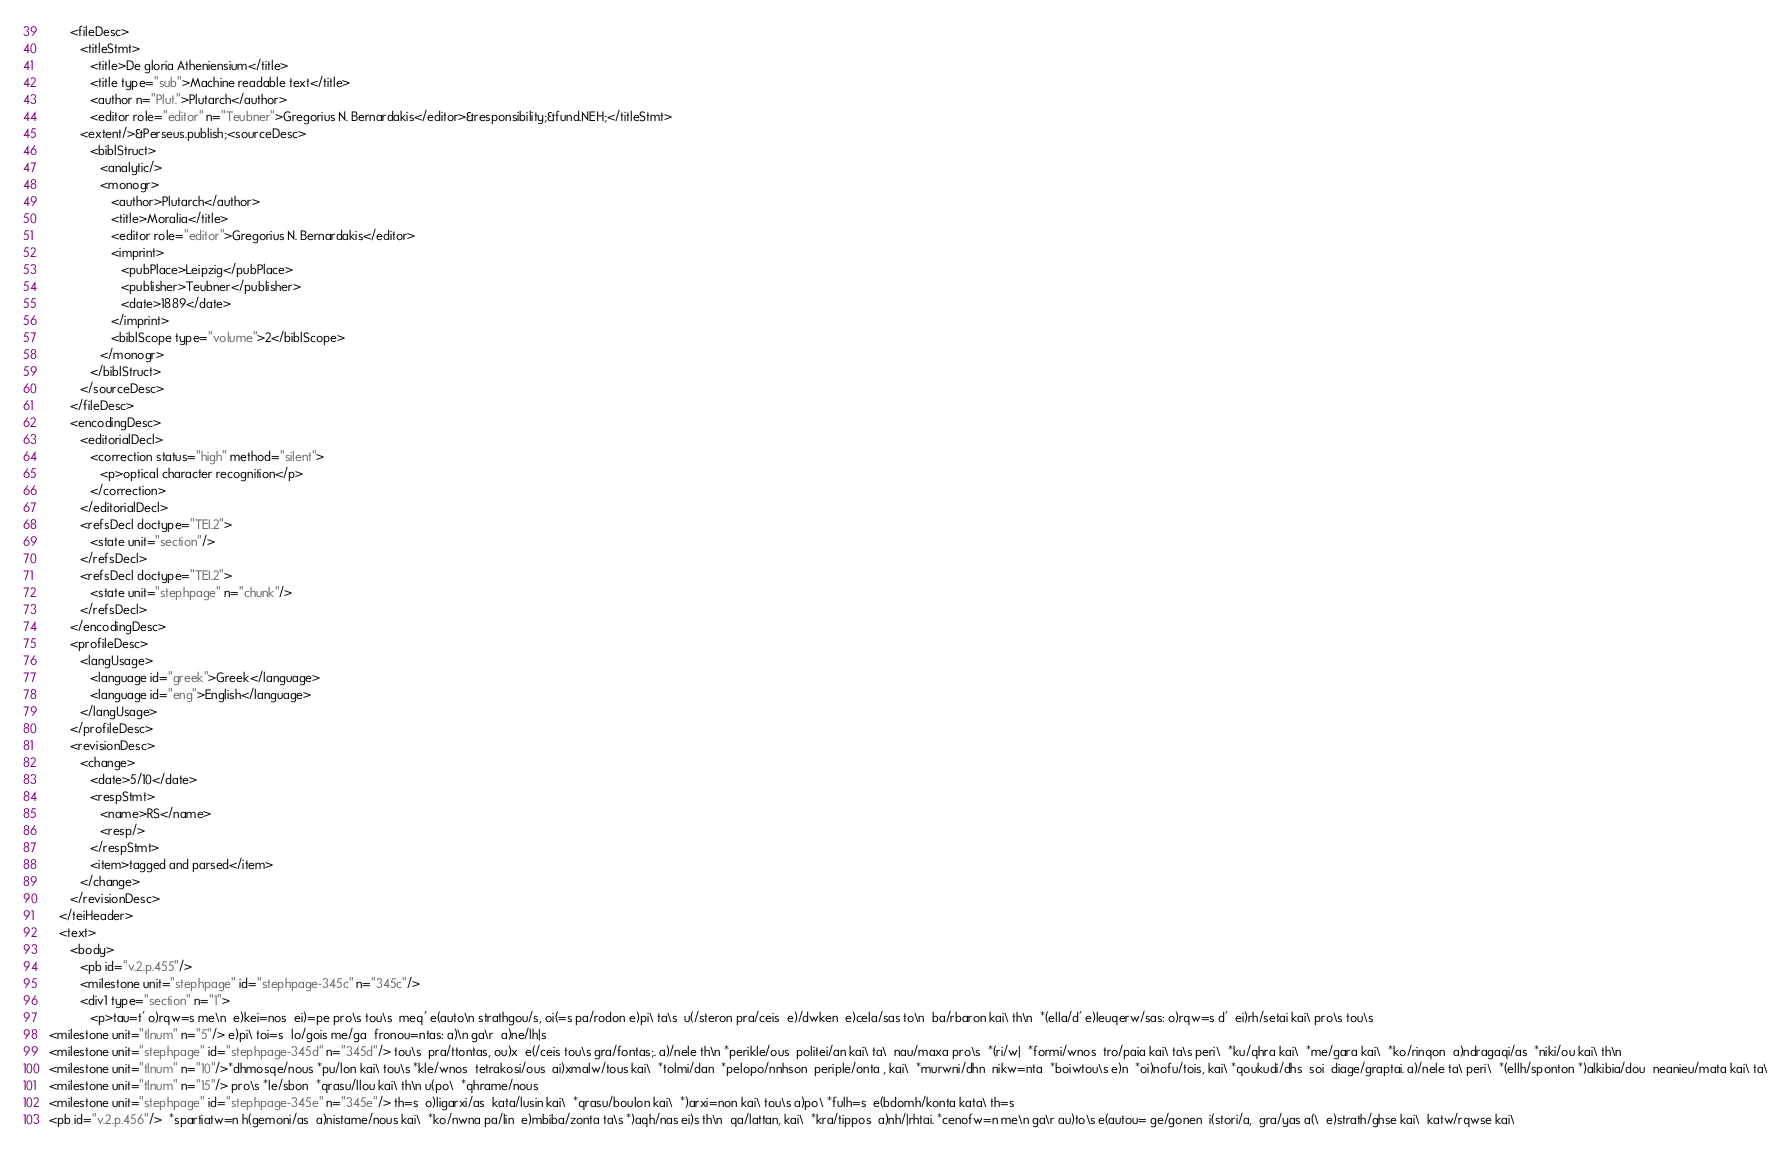Convert code to text. <code><loc_0><loc_0><loc_500><loc_500><_XML_>      <fileDesc>
         <titleStmt>
            <title>De gloria Atheniensium</title>
            <title type="sub">Machine readable text</title>
            <author n="Plut.">Plutarch</author>
            <editor role="editor" n="Teubner">Gregorius N. Bernardakis</editor>&responsibility;&fund.NEH;</titleStmt>
         <extent/>&Perseus.publish;<sourceDesc>
            <biblStruct>
               <analytic/>
               <monogr>
                  <author>Plutarch</author>
                  <title>Moralia</title>
                  <editor role="editor">Gregorius N. Bernardakis</editor>
                  <imprint>
                     <pubPlace>Leipzig</pubPlace>
                     <publisher>Teubner</publisher>
                     <date>1889</date>
                  </imprint>
                  <biblScope type="volume">2</biblScope>
               </monogr>
            </biblStruct>
         </sourceDesc>
      </fileDesc>
      <encodingDesc>
         <editorialDecl>
            <correction status="high" method="silent">
               <p>optical character recognition</p>
            </correction>
         </editorialDecl>
         <refsDecl doctype="TEI.2">
            <state unit="section"/>
         </refsDecl>
         <refsDecl doctype="TEI.2">
            <state unit="stephpage" n="chunk"/>
         </refsDecl>
      </encodingDesc>
      <profileDesc>
         <langUsage>
            <language id="greek">Greek</language>
            <language id="eng">English</language>
         </langUsage>
      </profileDesc>
      <revisionDesc>
         <change>
            <date>5/10</date>
            <respStmt>
               <name>RS</name>
               <resp/>
            </respStmt>
            <item>tagged and parsed</item>
         </change>
      </revisionDesc>
   </teiHeader>
   <text>
      <body>
         <pb id="v.2.p.455"/>
         <milestone unit="stephpage" id="stephpage-345c" n="345c"/>
         <div1 type="section" n="1">
            <p>tau=t' o)rqw=s me\n  e)kei=nos  ei)=pe pro\s tou\s  meq' e(auto\n strathgou/s, oi(=s pa/rodon e)pi\ ta\s  u(/steron pra/ceis  e)/dwken  e)cela/sas to\n  ba/rbaron kai\ th\n  *(ella/d' e)leuqerw/sas: o)rqw=s d'  ei)rh/setai kai\ pro\s tou\s
<milestone unit="tlnum" n="5"/> e)pi\ toi=s  lo/gois me/ga  fronou=ntas: a)\n ga\r  a)ne/lh|s
<milestone unit="stephpage" id="stephpage-345d" n="345d"/> tou\s  pra/ttontas, ou)x  e(/ceis tou\s gra/fontas;. a)/nele th\n *perikle/ous  politei/an kai\ ta\  nau/maxa pro\s  *(ri/w|  *formi/wnos  tro/paia kai\ ta\s peri\  *ku/qhra kai\  *me/gara kai\  *ko/rinqon  a)ndragaqi/as  *niki/ou kai\ th\n
<milestone unit="tlnum" n="10"/>*dhmosqe/nous *pu/lon kai\ tou\s *kle/wnos  tetrakosi/ous  ai)xmalw/tous kai\  *tolmi/dan  *pelopo/nnhson  periple/onta , kai\  *murwni/dhn  nikw=nta  *boiwtou\s e)n  *oi)nofu/tois, kai\ *qoukudi/dhs  soi  diage/graptai. a)/nele ta\ peri\  *(ellh/sponton *)alkibia/dou  neanieu/mata kai\ ta\
<milestone unit="tlnum" n="15"/> pro\s *le/sbon  *qrasu/llou kai\ th\n u(po\  *qhrame/nous
<milestone unit="stephpage" id="stephpage-345e" n="345e"/> th=s  o)ligarxi/as  kata/lusin kai\  *qrasu/boulon kai\  *)arxi=non kai\ tou\s a)po\ *fulh=s  e(bdomh/konta kata\ th=s
<pb id="v.2.p.456"/>  *spartiatw=n h(gemoni/as  a)nistame/nous kai\  *ko/nwna pa/lin  e)mbiba/zonta ta\s *)aqh/nas ei)s th\n  qa/lattan, kai\  *kra/tippos  a)nh/|rhtai. *cenofw=n me\n ga\r au)to\s e(autou= ge/gonen  i(stori/a,  gra/yas a(\  e)strath/ghse kai\  katw/rqwse kai\</code> 